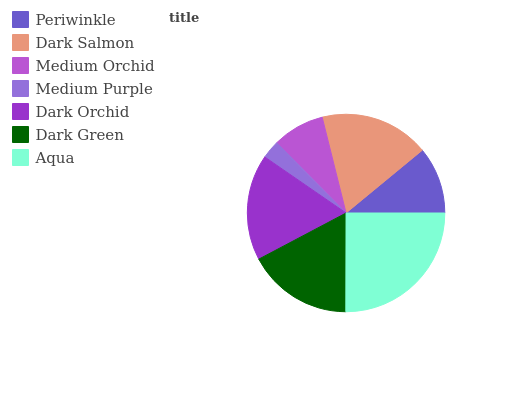Is Medium Purple the minimum?
Answer yes or no. Yes. Is Aqua the maximum?
Answer yes or no. Yes. Is Dark Salmon the minimum?
Answer yes or no. No. Is Dark Salmon the maximum?
Answer yes or no. No. Is Dark Salmon greater than Periwinkle?
Answer yes or no. Yes. Is Periwinkle less than Dark Salmon?
Answer yes or no. Yes. Is Periwinkle greater than Dark Salmon?
Answer yes or no. No. Is Dark Salmon less than Periwinkle?
Answer yes or no. No. Is Dark Green the high median?
Answer yes or no. Yes. Is Dark Green the low median?
Answer yes or no. Yes. Is Aqua the high median?
Answer yes or no. No. Is Dark Salmon the low median?
Answer yes or no. No. 